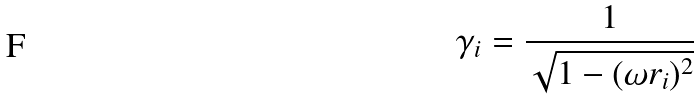<formula> <loc_0><loc_0><loc_500><loc_500>\gamma _ { i } = \frac { 1 } { \sqrt { 1 - ( \omega r _ { i } ) ^ { 2 } } }</formula> 